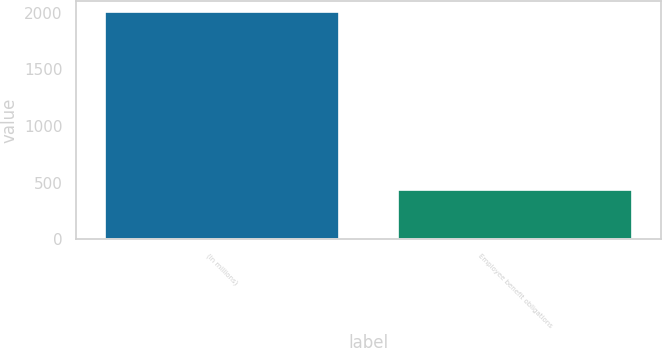<chart> <loc_0><loc_0><loc_500><loc_500><bar_chart><fcel>(in millions)<fcel>Employee benefit obligations<nl><fcel>2005<fcel>439<nl></chart> 